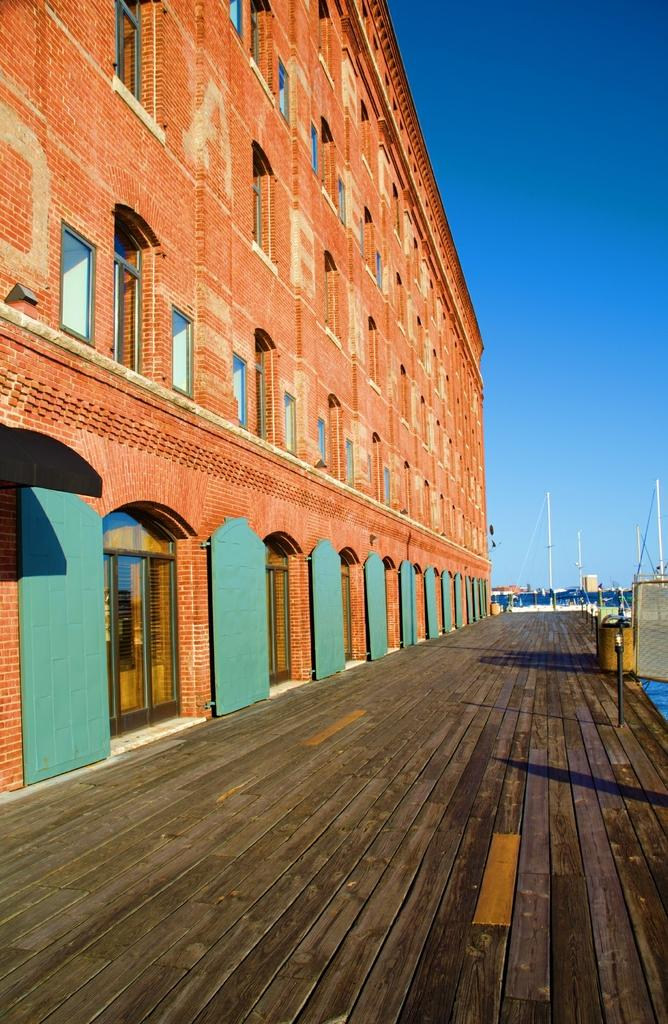What structure is located on the left side of the image? There is a building on the left side of the image. What is at the bottom of the image? There is a walkway at the bottom of the image. What can be seen in the background of the image? There are poles in the background of the image. What is visible at the top of the image? The sky is visible at the top of the image. Can you tell me how many friends are running with a rod in the image? There are no friends, running, or rods present in the image. 